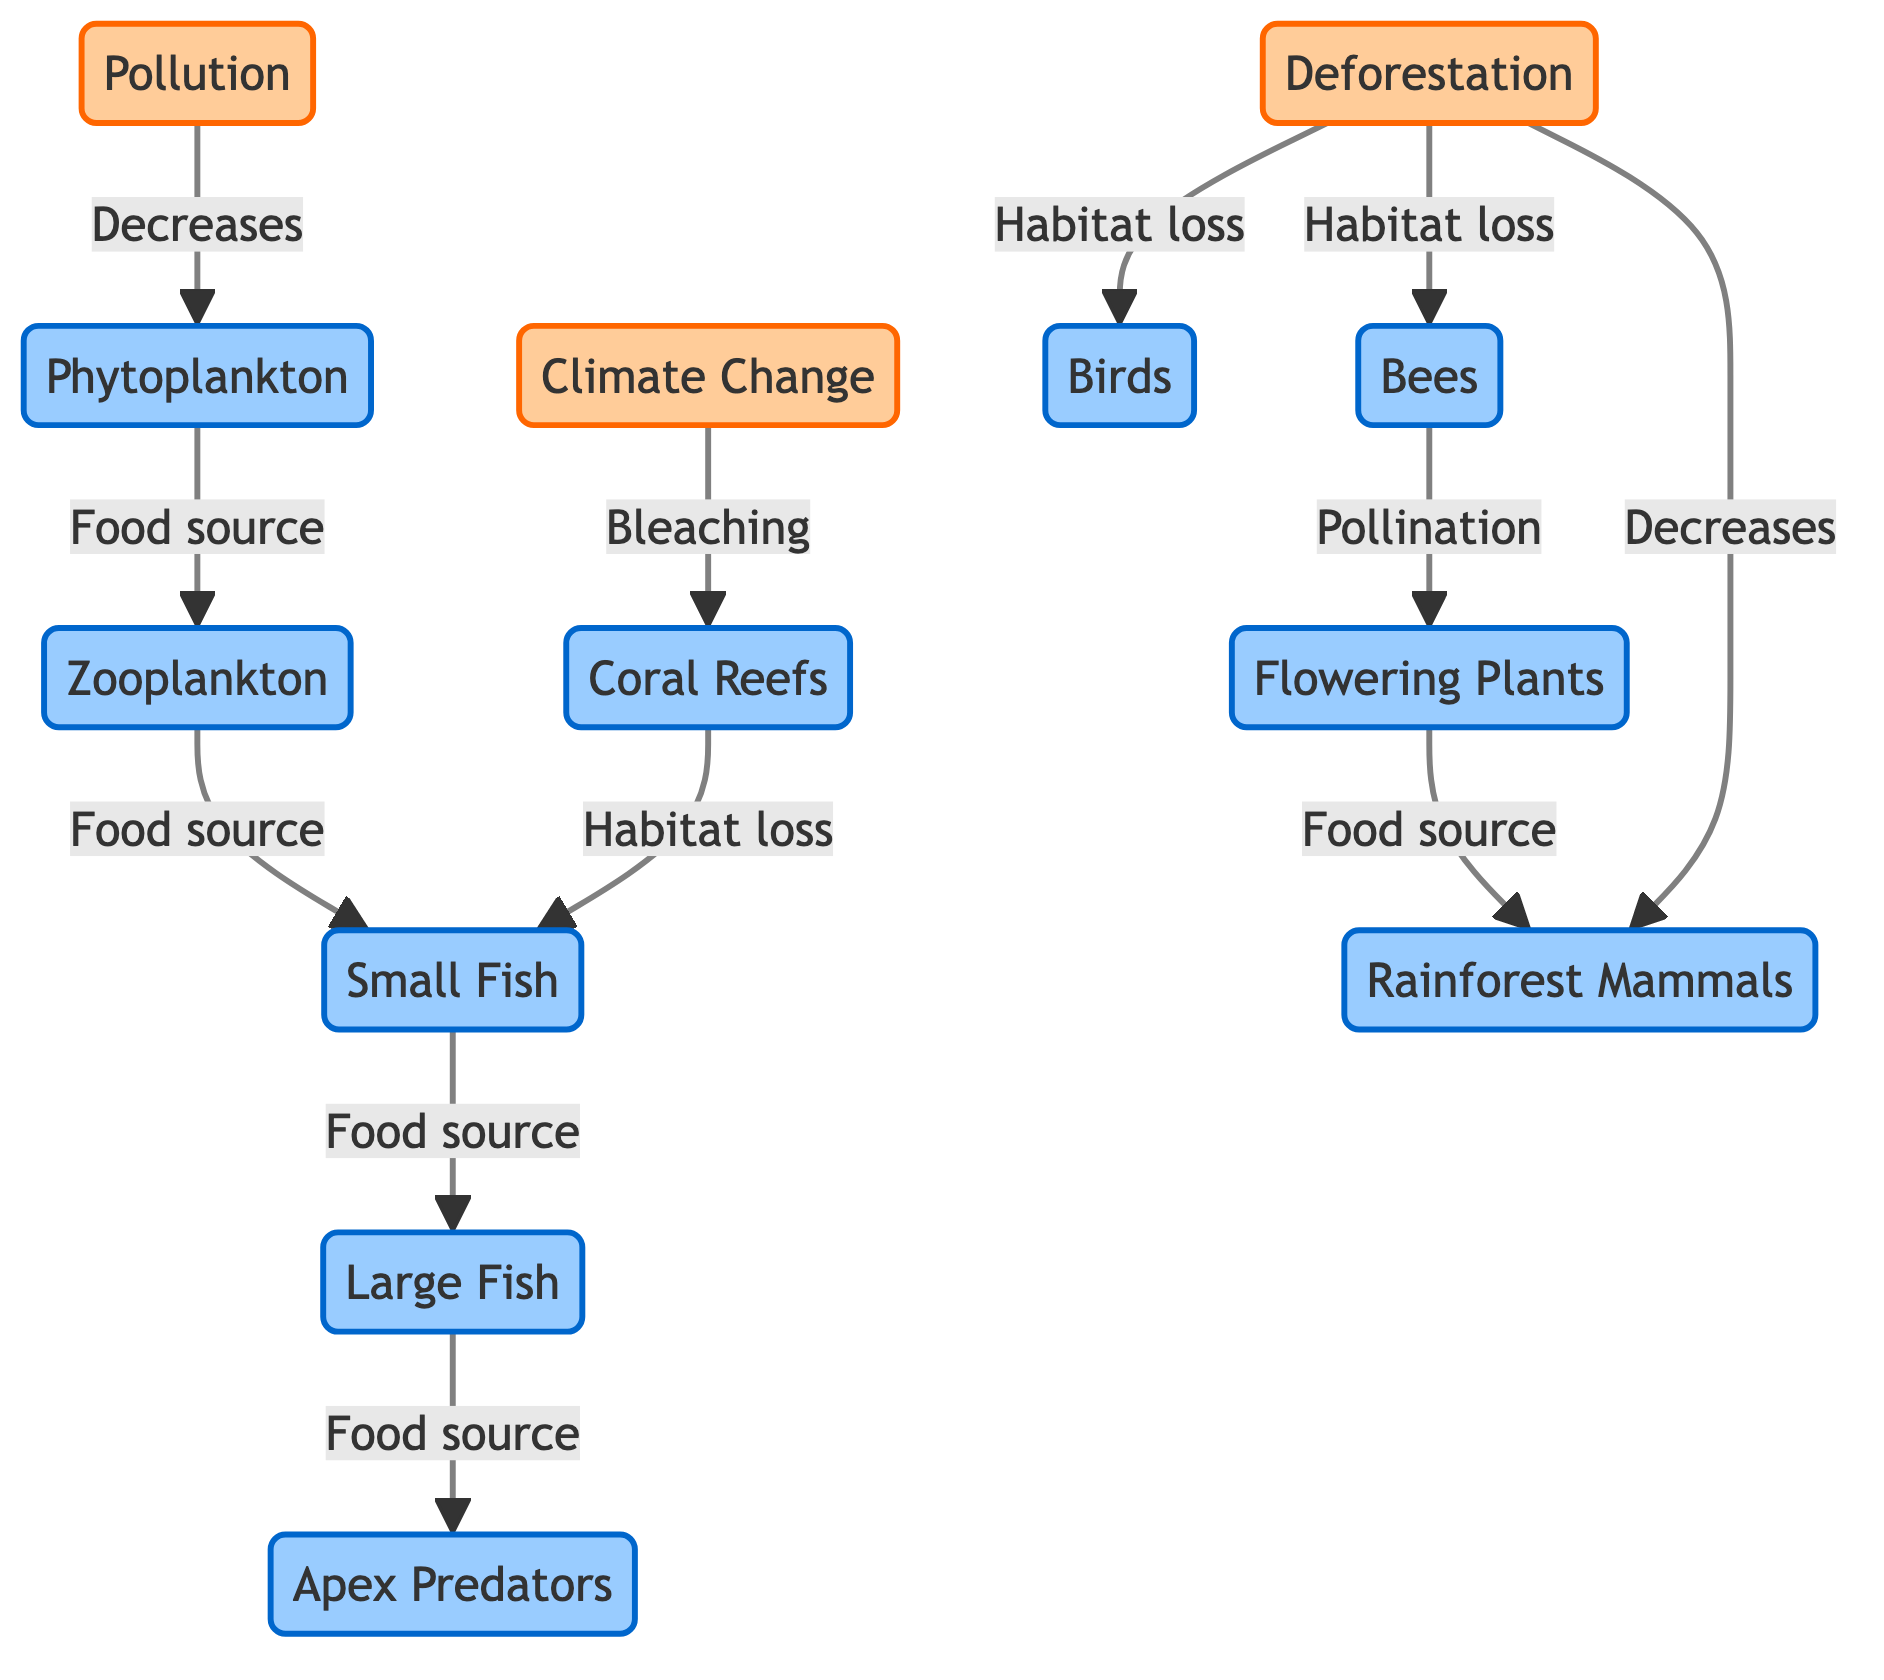What are the three main human impacts shown in the diagram? The diagram explicitly lists three human impacts: Pollution, Deforestation, and Climate Change.
Answer: Pollution, Deforestation, Climate Change How many organisms are affected by deforestation according to the diagram? The diagram shows that deforestation affects three organisms: Birds, Bees, and Rainforest Mammals.
Answer: Three What type of loss is caused by climate change to coral reefs? The diagram indicates that climate change causes "Bleaching" to coral reefs.
Answer: Bleaching What is the consequence of pollution on phytoplankton? The diagram shows that pollution "Decreases" phytoplankton.
Answer: Decreases How do bees relate to flowering plants in the diagram? The diagram indicates that bees provide "Pollination" to flowering plants.
Answer: Pollination What happens to small fish as a result of coral reef habitat loss? According to the diagram, small fish experience "Habitat loss" due to the bleaching of coral reefs.
Answer: Habitat loss Which organism acts as a food source for apex predators? The diagram illustrates that large fish are a food source for apex predators.
Answer: Large Fish What is the flow relationship between zooplankton and small fish? The diagram describes that zooplankton is a "Food source" for small fish.
Answer: Food source Which human impact directly causes the decrease of rainforest mammals? The diagram indicates that deforestation directly "Decreases" rainforest mammals.
Answer: Decreases 